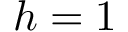<formula> <loc_0><loc_0><loc_500><loc_500>h = 1</formula> 